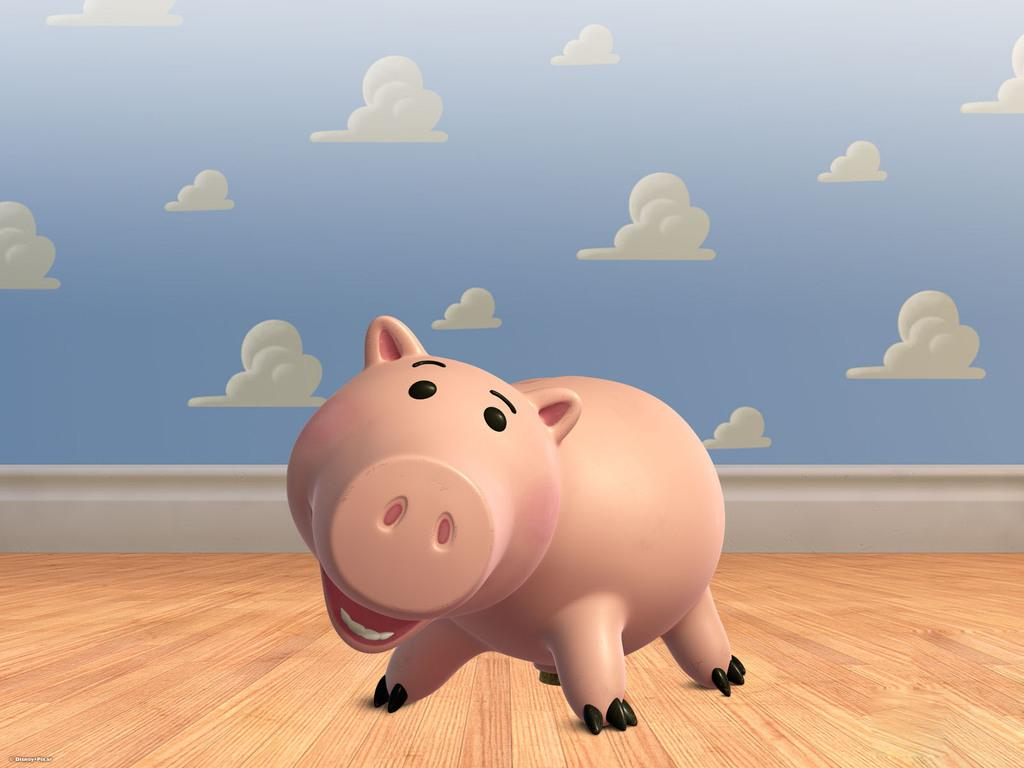What type of animal is in the picture? There is an animated pig in the picture. Where is the pig located in the image? The pig is present on the floor. What can be seen in the sky in the picture? There are clouds visible in the picture. What type of news can be heard coming from the fairies in the image? There are no fairies present in the image, and therefore no news can be heard from them. 